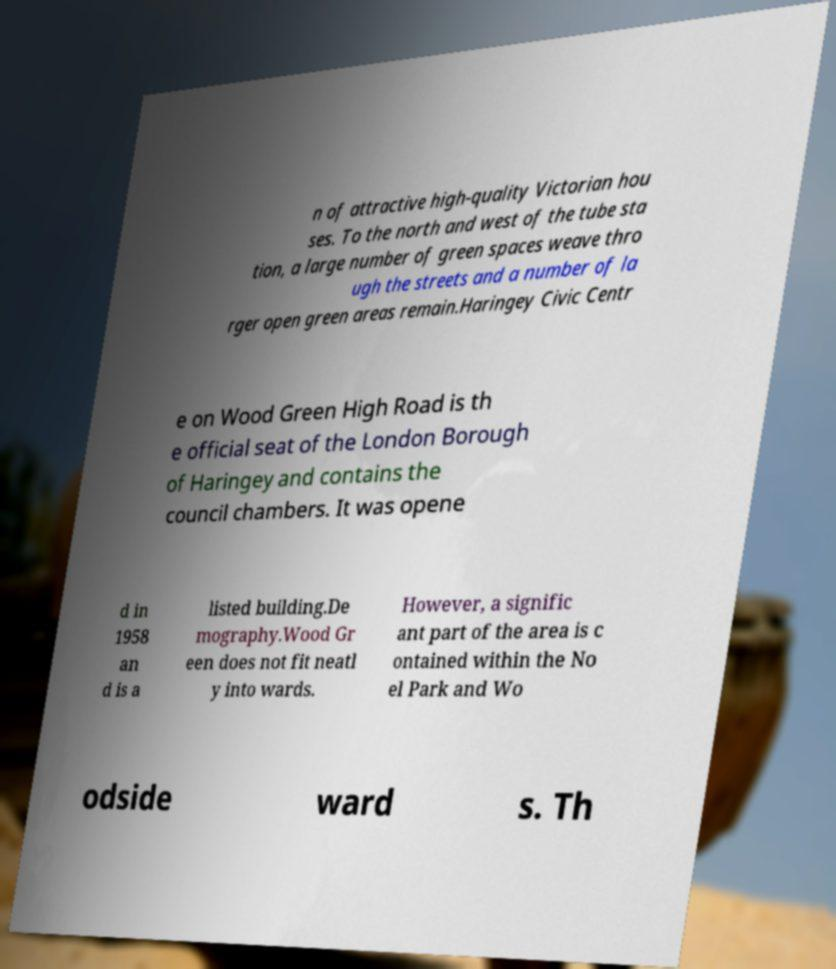What messages or text are displayed in this image? I need them in a readable, typed format. n of attractive high-quality Victorian hou ses. To the north and west of the tube sta tion, a large number of green spaces weave thro ugh the streets and a number of la rger open green areas remain.Haringey Civic Centr e on Wood Green High Road is th e official seat of the London Borough of Haringey and contains the council chambers. It was opene d in 1958 an d is a listed building.De mography.Wood Gr een does not fit neatl y into wards. However, a signific ant part of the area is c ontained within the No el Park and Wo odside ward s. Th 